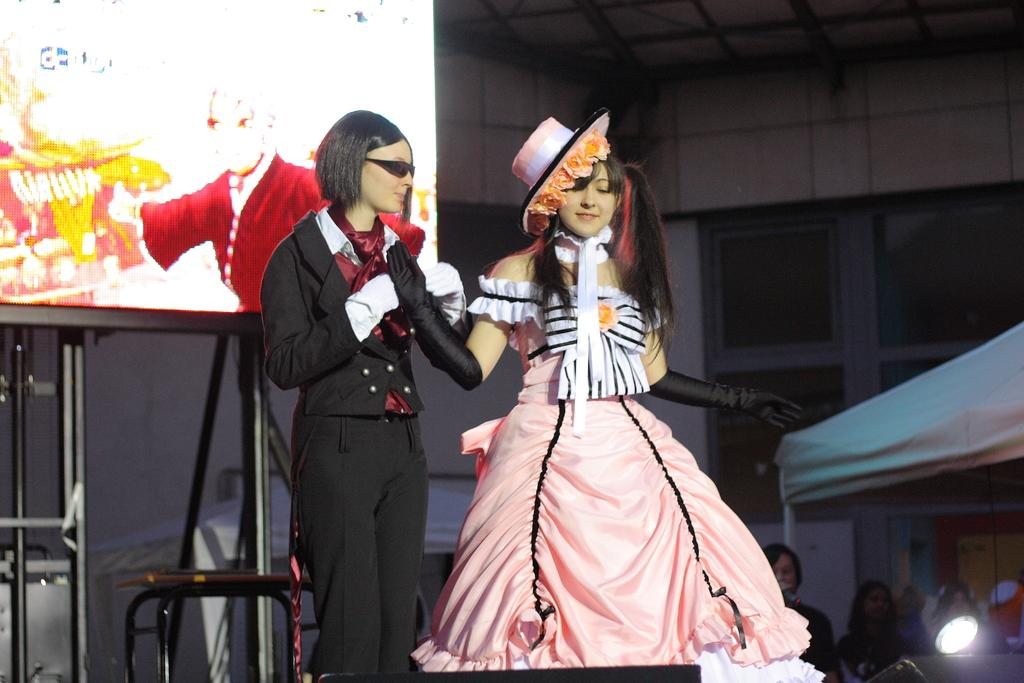Who or what can be seen in the image? There are people in the image. What is located in the top left corner of the image? There is a screen and metal rods in the top left corner of the image. What structure is on the right side of the image? There is a tent on the right side of the image. Can you describe the lighting in the image? There is a light in the image. What type of bait is being used by the people in the image? There is no bait present in the image; it does not depict any fishing or hunting activity. What type of pan is being used by the people in the image? There is no pan visible in the image. 